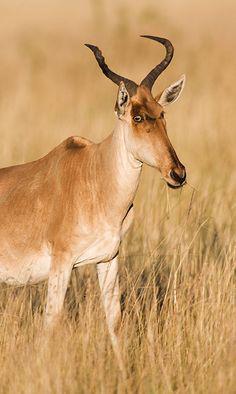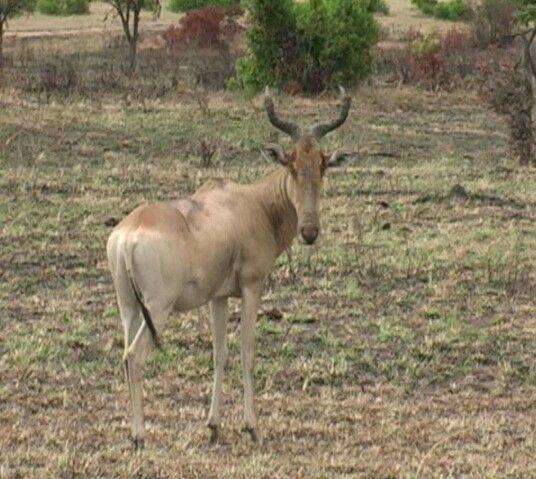The first image is the image on the left, the second image is the image on the right. Evaluate the accuracy of this statement regarding the images: "The right image contains one horned animal with its body turned rightward, and the left image contains at least five horned animals.". Is it true? Answer yes or no. No. The first image is the image on the left, the second image is the image on the right. Evaluate the accuracy of this statement regarding the images: "There are more then six of these antelope-like creatures.". Is it true? Answer yes or no. No. 